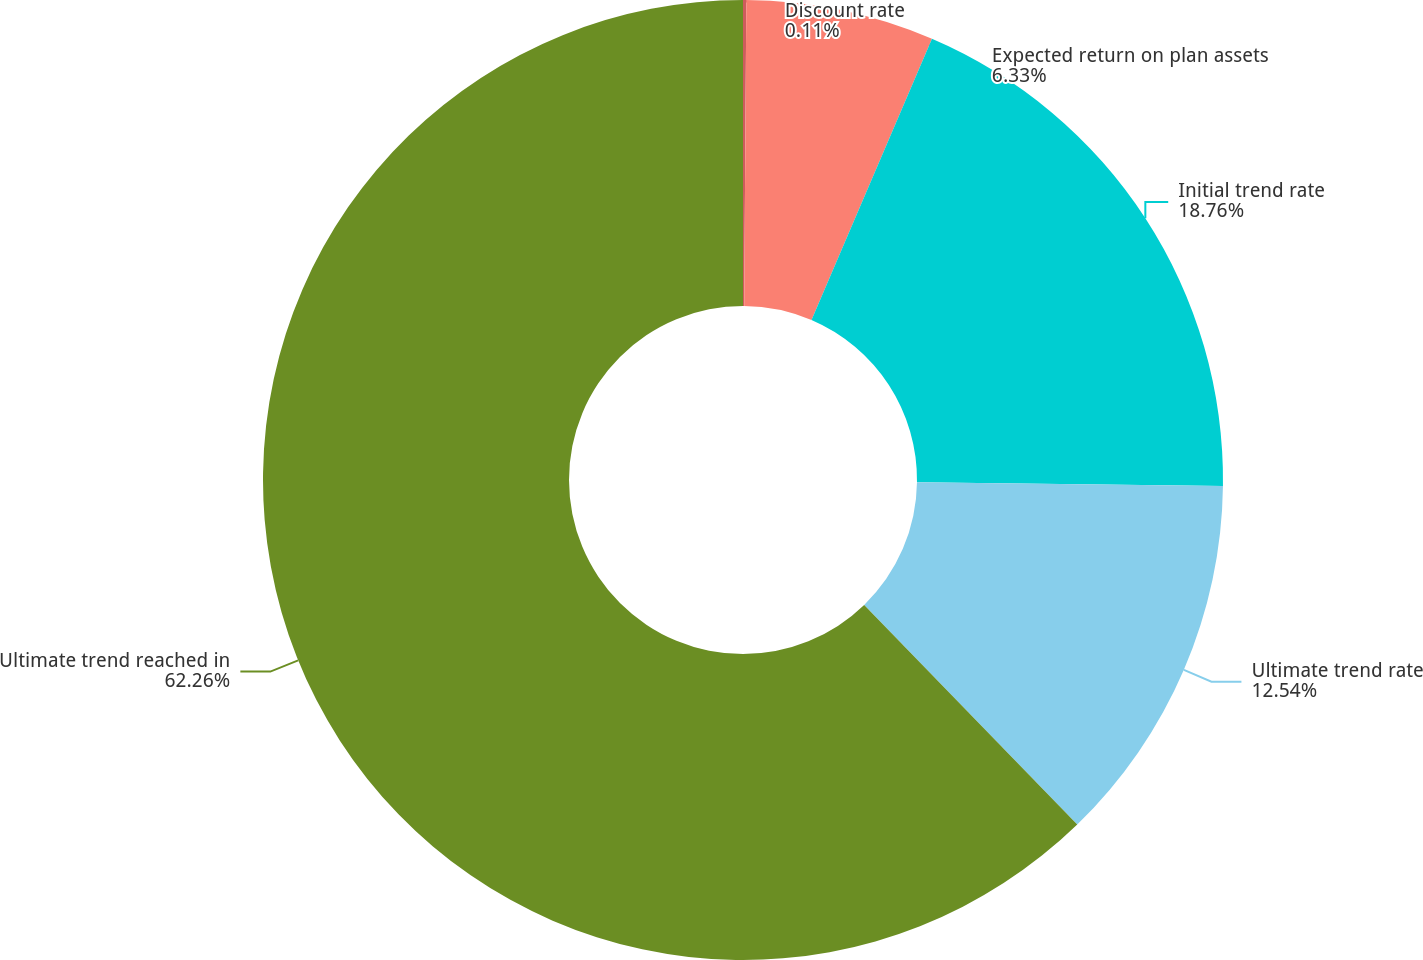<chart> <loc_0><loc_0><loc_500><loc_500><pie_chart><fcel>Discount rate<fcel>Expected return on plan assets<fcel>Initial trend rate<fcel>Ultimate trend rate<fcel>Ultimate trend reached in<nl><fcel>0.11%<fcel>6.33%<fcel>18.76%<fcel>12.54%<fcel>62.26%<nl></chart> 